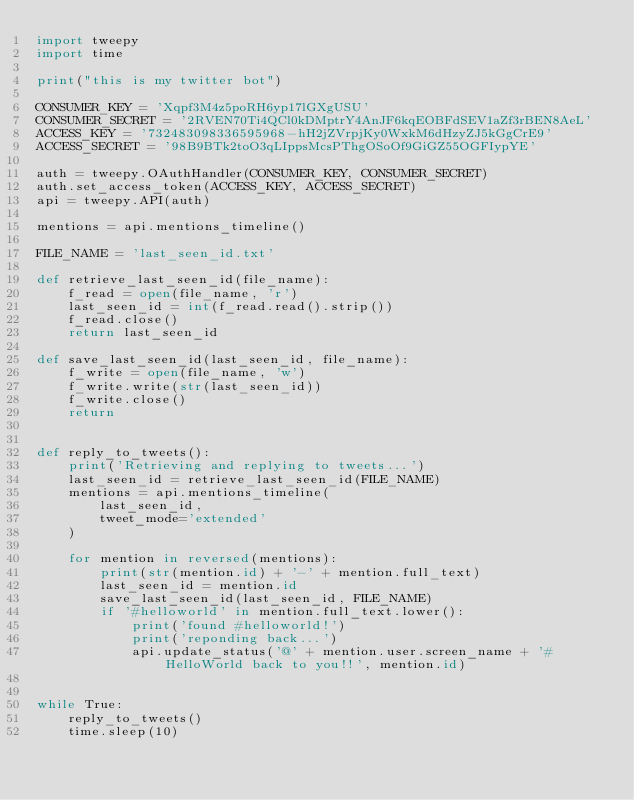Convert code to text. <code><loc_0><loc_0><loc_500><loc_500><_Python_>import tweepy
import time

print("this is my twitter bot")

CONSUMER_KEY = 'Xqpf3M4z5poRH6yp17lGXgUSU'
CONSUMER_SECRET = '2RVEN70Ti4QCl0kDMptrY4AnJF6kqEOBFdSEV1aZf3rBEN8AeL'
ACCESS_KEY = '732483098336595968-hH2jZVrpjKy0WxkM6dHzyZJ5kGgCrE9'
ACCESS_SECRET = '98B9BTk2toO3qLIppsMcsPThgOSoOf9GiGZ55OGFIypYE'

auth = tweepy.OAuthHandler(CONSUMER_KEY, CONSUMER_SECRET)
auth.set_access_token(ACCESS_KEY, ACCESS_SECRET)
api = tweepy.API(auth)

mentions = api.mentions_timeline()

FILE_NAME = 'last_seen_id.txt'

def retrieve_last_seen_id(file_name):
    f_read = open(file_name, 'r')
    last_seen_id = int(f_read.read().strip())
    f_read.close()
    return last_seen_id

def save_last_seen_id(last_seen_id, file_name):
    f_write = open(file_name, 'w')
    f_write.write(str(last_seen_id))
    f_write.close()
    return


def reply_to_tweets():
    print('Retrieving and replying to tweets...')
    last_seen_id = retrieve_last_seen_id(FILE_NAME)
    mentions = api.mentions_timeline(
        last_seen_id,
        tweet_mode='extended'
    )

    for mention in reversed(mentions):
        print(str(mention.id) + '-' + mention.full_text)
        last_seen_id = mention.id
        save_last_seen_id(last_seen_id, FILE_NAME)
        if '#helloworld' in mention.full_text.lower():
            print('found #helloworld!')
            print('reponding back...')
            api.update_status('@' + mention.user.screen_name + '#HelloWorld back to you!!', mention.id)


while True:
    reply_to_tweets()
    time.sleep(10)

</code> 